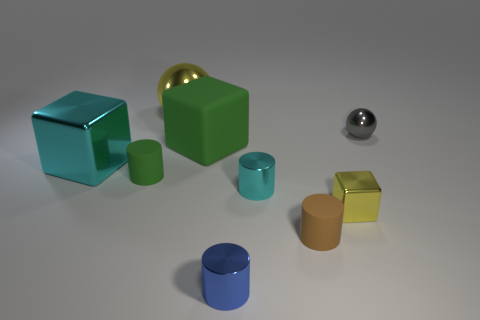There is a thing that is right of the yellow thing that is to the right of the cyan thing to the right of the blue cylinder; what is its material?
Your answer should be compact. Metal. Are there any other objects made of the same material as the brown thing?
Give a very brief answer. Yes. Is the tiny blue object made of the same material as the tiny cyan cylinder?
Your answer should be compact. Yes. How many spheres are either large yellow metallic objects or tiny green matte objects?
Provide a short and direct response. 1. What is the color of the tiny sphere that is the same material as the large cyan object?
Give a very brief answer. Gray. Are there fewer big metallic things than tiny purple metal balls?
Make the answer very short. No. There is a green rubber thing that is in front of the big matte thing; is it the same shape as the brown matte thing that is in front of the big metal sphere?
Offer a very short reply. Yes. What number of things are either small yellow metal cubes or large purple cubes?
Offer a terse response. 1. There is a shiny cube that is the same size as the brown object; what color is it?
Make the answer very short. Yellow. What number of tiny rubber objects are in front of the yellow metal thing on the right side of the big green cube?
Offer a very short reply. 1. 